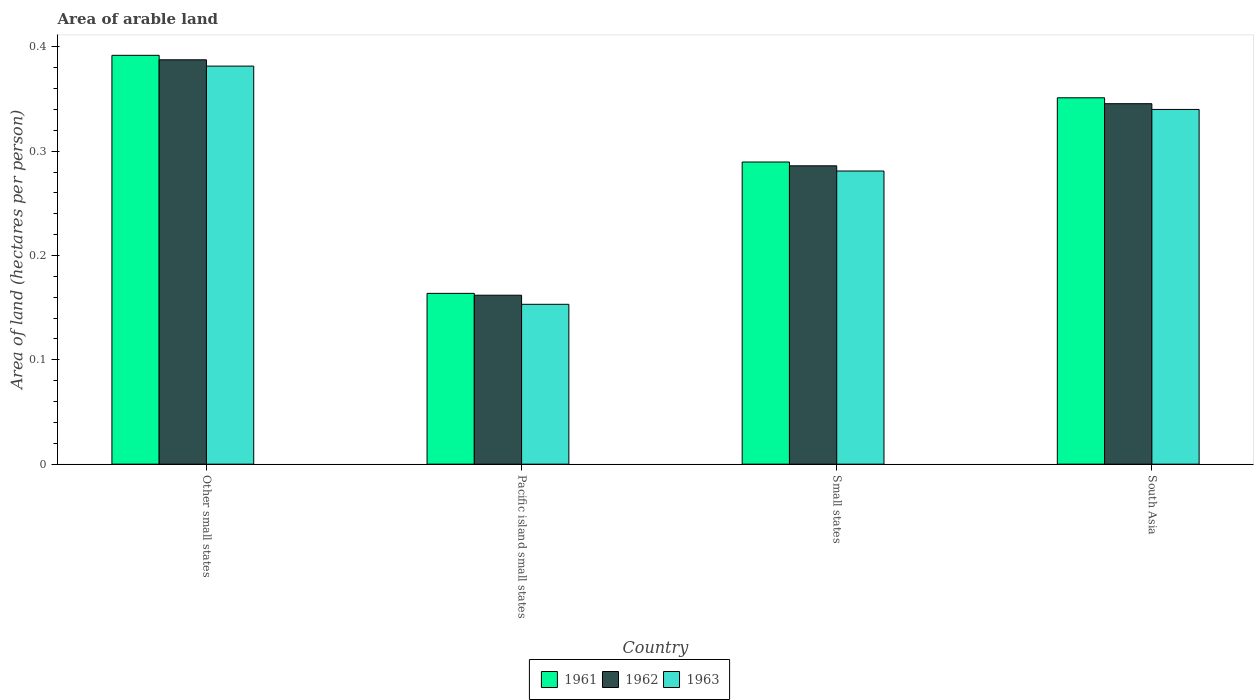Are the number of bars per tick equal to the number of legend labels?
Your response must be concise. Yes. Are the number of bars on each tick of the X-axis equal?
Provide a succinct answer. Yes. How many bars are there on the 3rd tick from the left?
Keep it short and to the point. 3. What is the label of the 1st group of bars from the left?
Make the answer very short. Other small states. What is the total arable land in 1961 in South Asia?
Keep it short and to the point. 0.35. Across all countries, what is the maximum total arable land in 1962?
Provide a succinct answer. 0.39. Across all countries, what is the minimum total arable land in 1962?
Give a very brief answer. 0.16. In which country was the total arable land in 1963 maximum?
Offer a very short reply. Other small states. In which country was the total arable land in 1961 minimum?
Provide a succinct answer. Pacific island small states. What is the total total arable land in 1962 in the graph?
Give a very brief answer. 1.18. What is the difference between the total arable land in 1961 in Small states and that in South Asia?
Your response must be concise. -0.06. What is the difference between the total arable land in 1963 in Pacific island small states and the total arable land in 1961 in South Asia?
Offer a terse response. -0.2. What is the average total arable land in 1962 per country?
Give a very brief answer. 0.3. What is the difference between the total arable land of/in 1961 and total arable land of/in 1962 in Small states?
Make the answer very short. 0. What is the ratio of the total arable land in 1962 in Other small states to that in Small states?
Your answer should be very brief. 1.36. What is the difference between the highest and the second highest total arable land in 1963?
Your response must be concise. 0.04. What is the difference between the highest and the lowest total arable land in 1962?
Your answer should be compact. 0.23. In how many countries, is the total arable land in 1961 greater than the average total arable land in 1961 taken over all countries?
Your answer should be very brief. 2. Is it the case that in every country, the sum of the total arable land in 1963 and total arable land in 1961 is greater than the total arable land in 1962?
Your answer should be compact. Yes. How many bars are there?
Provide a short and direct response. 12. How many countries are there in the graph?
Ensure brevity in your answer.  4. Does the graph contain any zero values?
Offer a very short reply. No. How many legend labels are there?
Make the answer very short. 3. How are the legend labels stacked?
Offer a very short reply. Horizontal. What is the title of the graph?
Offer a terse response. Area of arable land. What is the label or title of the X-axis?
Provide a succinct answer. Country. What is the label or title of the Y-axis?
Provide a succinct answer. Area of land (hectares per person). What is the Area of land (hectares per person) of 1961 in Other small states?
Your response must be concise. 0.39. What is the Area of land (hectares per person) in 1962 in Other small states?
Your response must be concise. 0.39. What is the Area of land (hectares per person) of 1963 in Other small states?
Provide a succinct answer. 0.38. What is the Area of land (hectares per person) in 1961 in Pacific island small states?
Make the answer very short. 0.16. What is the Area of land (hectares per person) in 1962 in Pacific island small states?
Your response must be concise. 0.16. What is the Area of land (hectares per person) in 1963 in Pacific island small states?
Give a very brief answer. 0.15. What is the Area of land (hectares per person) of 1961 in Small states?
Make the answer very short. 0.29. What is the Area of land (hectares per person) of 1962 in Small states?
Provide a short and direct response. 0.29. What is the Area of land (hectares per person) of 1963 in Small states?
Your answer should be very brief. 0.28. What is the Area of land (hectares per person) of 1961 in South Asia?
Your answer should be very brief. 0.35. What is the Area of land (hectares per person) in 1962 in South Asia?
Give a very brief answer. 0.35. What is the Area of land (hectares per person) of 1963 in South Asia?
Make the answer very short. 0.34. Across all countries, what is the maximum Area of land (hectares per person) of 1961?
Your response must be concise. 0.39. Across all countries, what is the maximum Area of land (hectares per person) in 1962?
Keep it short and to the point. 0.39. Across all countries, what is the maximum Area of land (hectares per person) in 1963?
Provide a short and direct response. 0.38. Across all countries, what is the minimum Area of land (hectares per person) of 1961?
Provide a short and direct response. 0.16. Across all countries, what is the minimum Area of land (hectares per person) of 1962?
Your answer should be very brief. 0.16. Across all countries, what is the minimum Area of land (hectares per person) in 1963?
Ensure brevity in your answer.  0.15. What is the total Area of land (hectares per person) in 1961 in the graph?
Offer a very short reply. 1.2. What is the total Area of land (hectares per person) in 1962 in the graph?
Provide a short and direct response. 1.18. What is the total Area of land (hectares per person) in 1963 in the graph?
Provide a short and direct response. 1.16. What is the difference between the Area of land (hectares per person) in 1961 in Other small states and that in Pacific island small states?
Your answer should be compact. 0.23. What is the difference between the Area of land (hectares per person) in 1962 in Other small states and that in Pacific island small states?
Provide a succinct answer. 0.23. What is the difference between the Area of land (hectares per person) of 1963 in Other small states and that in Pacific island small states?
Your response must be concise. 0.23. What is the difference between the Area of land (hectares per person) of 1961 in Other small states and that in Small states?
Make the answer very short. 0.1. What is the difference between the Area of land (hectares per person) of 1962 in Other small states and that in Small states?
Make the answer very short. 0.1. What is the difference between the Area of land (hectares per person) in 1963 in Other small states and that in Small states?
Your answer should be compact. 0.1. What is the difference between the Area of land (hectares per person) of 1961 in Other small states and that in South Asia?
Give a very brief answer. 0.04. What is the difference between the Area of land (hectares per person) in 1962 in Other small states and that in South Asia?
Ensure brevity in your answer.  0.04. What is the difference between the Area of land (hectares per person) of 1963 in Other small states and that in South Asia?
Provide a succinct answer. 0.04. What is the difference between the Area of land (hectares per person) of 1961 in Pacific island small states and that in Small states?
Your answer should be very brief. -0.13. What is the difference between the Area of land (hectares per person) in 1962 in Pacific island small states and that in Small states?
Give a very brief answer. -0.12. What is the difference between the Area of land (hectares per person) in 1963 in Pacific island small states and that in Small states?
Provide a short and direct response. -0.13. What is the difference between the Area of land (hectares per person) of 1961 in Pacific island small states and that in South Asia?
Your response must be concise. -0.19. What is the difference between the Area of land (hectares per person) in 1962 in Pacific island small states and that in South Asia?
Your answer should be compact. -0.18. What is the difference between the Area of land (hectares per person) of 1963 in Pacific island small states and that in South Asia?
Your response must be concise. -0.19. What is the difference between the Area of land (hectares per person) of 1961 in Small states and that in South Asia?
Give a very brief answer. -0.06. What is the difference between the Area of land (hectares per person) of 1962 in Small states and that in South Asia?
Offer a terse response. -0.06. What is the difference between the Area of land (hectares per person) in 1963 in Small states and that in South Asia?
Your response must be concise. -0.06. What is the difference between the Area of land (hectares per person) in 1961 in Other small states and the Area of land (hectares per person) in 1962 in Pacific island small states?
Your answer should be very brief. 0.23. What is the difference between the Area of land (hectares per person) in 1961 in Other small states and the Area of land (hectares per person) in 1963 in Pacific island small states?
Your answer should be very brief. 0.24. What is the difference between the Area of land (hectares per person) of 1962 in Other small states and the Area of land (hectares per person) of 1963 in Pacific island small states?
Make the answer very short. 0.23. What is the difference between the Area of land (hectares per person) in 1961 in Other small states and the Area of land (hectares per person) in 1962 in Small states?
Your answer should be very brief. 0.11. What is the difference between the Area of land (hectares per person) in 1961 in Other small states and the Area of land (hectares per person) in 1963 in Small states?
Provide a succinct answer. 0.11. What is the difference between the Area of land (hectares per person) in 1962 in Other small states and the Area of land (hectares per person) in 1963 in Small states?
Ensure brevity in your answer.  0.11. What is the difference between the Area of land (hectares per person) in 1961 in Other small states and the Area of land (hectares per person) in 1962 in South Asia?
Ensure brevity in your answer.  0.05. What is the difference between the Area of land (hectares per person) in 1961 in Other small states and the Area of land (hectares per person) in 1963 in South Asia?
Your response must be concise. 0.05. What is the difference between the Area of land (hectares per person) in 1962 in Other small states and the Area of land (hectares per person) in 1963 in South Asia?
Your answer should be very brief. 0.05. What is the difference between the Area of land (hectares per person) of 1961 in Pacific island small states and the Area of land (hectares per person) of 1962 in Small states?
Offer a terse response. -0.12. What is the difference between the Area of land (hectares per person) in 1961 in Pacific island small states and the Area of land (hectares per person) in 1963 in Small states?
Your answer should be compact. -0.12. What is the difference between the Area of land (hectares per person) in 1962 in Pacific island small states and the Area of land (hectares per person) in 1963 in Small states?
Offer a terse response. -0.12. What is the difference between the Area of land (hectares per person) in 1961 in Pacific island small states and the Area of land (hectares per person) in 1962 in South Asia?
Give a very brief answer. -0.18. What is the difference between the Area of land (hectares per person) in 1961 in Pacific island small states and the Area of land (hectares per person) in 1963 in South Asia?
Keep it short and to the point. -0.18. What is the difference between the Area of land (hectares per person) in 1962 in Pacific island small states and the Area of land (hectares per person) in 1963 in South Asia?
Ensure brevity in your answer.  -0.18. What is the difference between the Area of land (hectares per person) in 1961 in Small states and the Area of land (hectares per person) in 1962 in South Asia?
Provide a short and direct response. -0.06. What is the difference between the Area of land (hectares per person) in 1961 in Small states and the Area of land (hectares per person) in 1963 in South Asia?
Your answer should be very brief. -0.05. What is the difference between the Area of land (hectares per person) of 1962 in Small states and the Area of land (hectares per person) of 1963 in South Asia?
Offer a terse response. -0.05. What is the average Area of land (hectares per person) of 1961 per country?
Give a very brief answer. 0.3. What is the average Area of land (hectares per person) of 1962 per country?
Give a very brief answer. 0.3. What is the average Area of land (hectares per person) in 1963 per country?
Ensure brevity in your answer.  0.29. What is the difference between the Area of land (hectares per person) in 1961 and Area of land (hectares per person) in 1962 in Other small states?
Provide a short and direct response. 0. What is the difference between the Area of land (hectares per person) in 1961 and Area of land (hectares per person) in 1963 in Other small states?
Provide a succinct answer. 0.01. What is the difference between the Area of land (hectares per person) of 1962 and Area of land (hectares per person) of 1963 in Other small states?
Give a very brief answer. 0.01. What is the difference between the Area of land (hectares per person) in 1961 and Area of land (hectares per person) in 1962 in Pacific island small states?
Ensure brevity in your answer.  0. What is the difference between the Area of land (hectares per person) of 1961 and Area of land (hectares per person) of 1963 in Pacific island small states?
Your answer should be compact. 0.01. What is the difference between the Area of land (hectares per person) in 1962 and Area of land (hectares per person) in 1963 in Pacific island small states?
Offer a very short reply. 0.01. What is the difference between the Area of land (hectares per person) of 1961 and Area of land (hectares per person) of 1962 in Small states?
Keep it short and to the point. 0. What is the difference between the Area of land (hectares per person) of 1961 and Area of land (hectares per person) of 1963 in Small states?
Keep it short and to the point. 0.01. What is the difference between the Area of land (hectares per person) of 1962 and Area of land (hectares per person) of 1963 in Small states?
Offer a terse response. 0.01. What is the difference between the Area of land (hectares per person) in 1961 and Area of land (hectares per person) in 1962 in South Asia?
Offer a very short reply. 0.01. What is the difference between the Area of land (hectares per person) in 1961 and Area of land (hectares per person) in 1963 in South Asia?
Your response must be concise. 0.01. What is the difference between the Area of land (hectares per person) in 1962 and Area of land (hectares per person) in 1963 in South Asia?
Keep it short and to the point. 0.01. What is the ratio of the Area of land (hectares per person) in 1961 in Other small states to that in Pacific island small states?
Your answer should be compact. 2.39. What is the ratio of the Area of land (hectares per person) in 1962 in Other small states to that in Pacific island small states?
Keep it short and to the point. 2.39. What is the ratio of the Area of land (hectares per person) of 1963 in Other small states to that in Pacific island small states?
Provide a succinct answer. 2.49. What is the ratio of the Area of land (hectares per person) in 1961 in Other small states to that in Small states?
Keep it short and to the point. 1.35. What is the ratio of the Area of land (hectares per person) in 1962 in Other small states to that in Small states?
Provide a succinct answer. 1.36. What is the ratio of the Area of land (hectares per person) in 1963 in Other small states to that in Small states?
Give a very brief answer. 1.36. What is the ratio of the Area of land (hectares per person) in 1961 in Other small states to that in South Asia?
Your answer should be very brief. 1.12. What is the ratio of the Area of land (hectares per person) in 1962 in Other small states to that in South Asia?
Your answer should be very brief. 1.12. What is the ratio of the Area of land (hectares per person) of 1963 in Other small states to that in South Asia?
Your answer should be very brief. 1.12. What is the ratio of the Area of land (hectares per person) of 1961 in Pacific island small states to that in Small states?
Provide a succinct answer. 0.57. What is the ratio of the Area of land (hectares per person) of 1962 in Pacific island small states to that in Small states?
Your response must be concise. 0.57. What is the ratio of the Area of land (hectares per person) in 1963 in Pacific island small states to that in Small states?
Your response must be concise. 0.55. What is the ratio of the Area of land (hectares per person) of 1961 in Pacific island small states to that in South Asia?
Give a very brief answer. 0.47. What is the ratio of the Area of land (hectares per person) of 1962 in Pacific island small states to that in South Asia?
Your answer should be very brief. 0.47. What is the ratio of the Area of land (hectares per person) of 1963 in Pacific island small states to that in South Asia?
Your answer should be compact. 0.45. What is the ratio of the Area of land (hectares per person) of 1961 in Small states to that in South Asia?
Keep it short and to the point. 0.82. What is the ratio of the Area of land (hectares per person) in 1962 in Small states to that in South Asia?
Your answer should be very brief. 0.83. What is the ratio of the Area of land (hectares per person) in 1963 in Small states to that in South Asia?
Offer a very short reply. 0.83. What is the difference between the highest and the second highest Area of land (hectares per person) of 1961?
Your answer should be very brief. 0.04. What is the difference between the highest and the second highest Area of land (hectares per person) in 1962?
Provide a succinct answer. 0.04. What is the difference between the highest and the second highest Area of land (hectares per person) of 1963?
Your answer should be very brief. 0.04. What is the difference between the highest and the lowest Area of land (hectares per person) in 1961?
Your response must be concise. 0.23. What is the difference between the highest and the lowest Area of land (hectares per person) of 1962?
Your answer should be compact. 0.23. What is the difference between the highest and the lowest Area of land (hectares per person) in 1963?
Give a very brief answer. 0.23. 